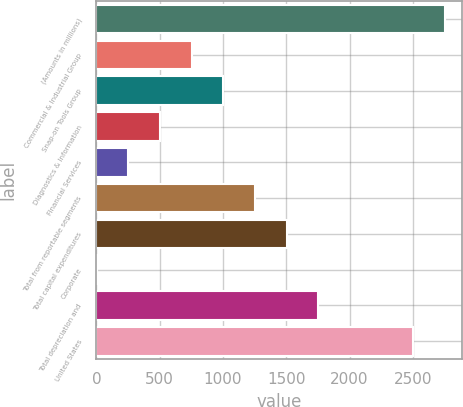<chart> <loc_0><loc_0><loc_500><loc_500><bar_chart><fcel>(Amounts in millions)<fcel>Commercial & Industrial Group<fcel>Snap-on Tools Group<fcel>Diagnostics & Information<fcel>Financial Services<fcel>Total from reportable segments<fcel>Total capital expenditures<fcel>Corporate<fcel>Total depreciation and<fcel>United States<nl><fcel>2754.43<fcel>751.79<fcel>1002.12<fcel>501.46<fcel>251.13<fcel>1252.45<fcel>1502.78<fcel>0.8<fcel>1753.11<fcel>2504.1<nl></chart> 